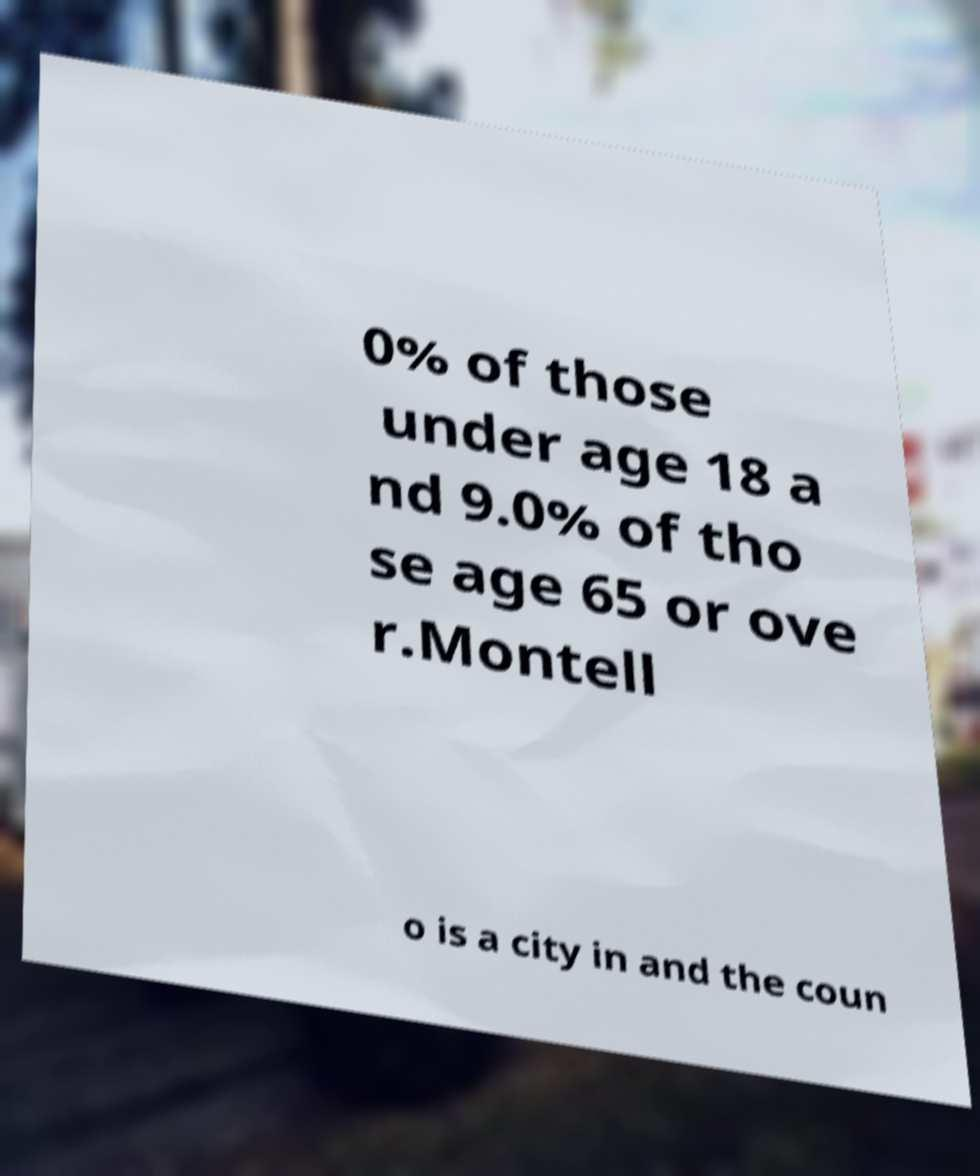Can you accurately transcribe the text from the provided image for me? 0% of those under age 18 a nd 9.0% of tho se age 65 or ove r.Montell o is a city in and the coun 